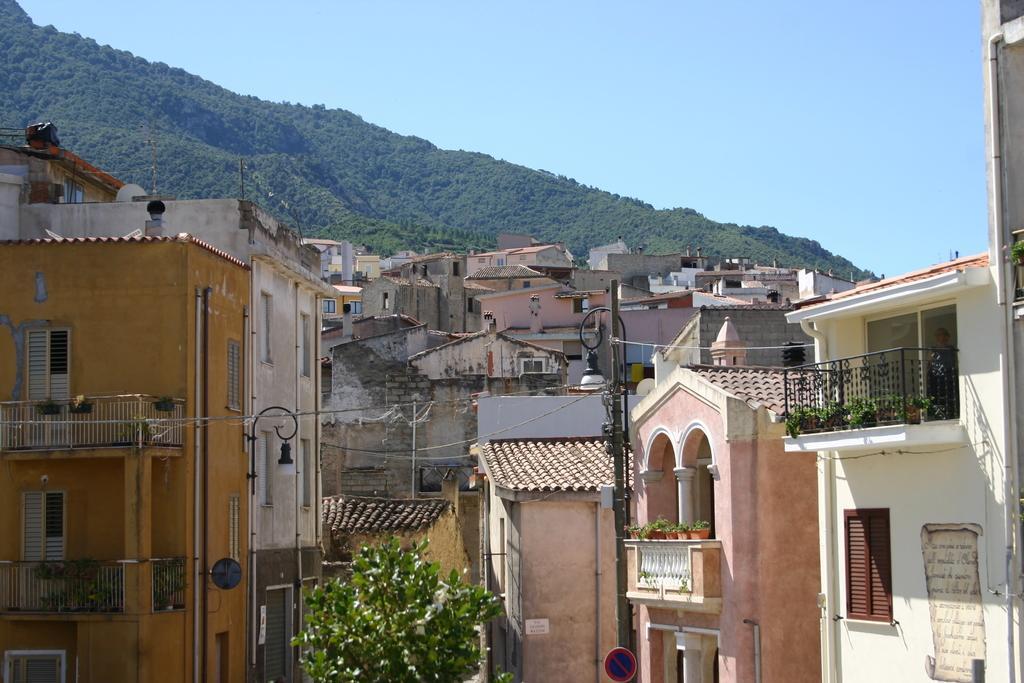Please provide a concise description of this image. This is a tree and these are the buildings, at the top it's a hill. 